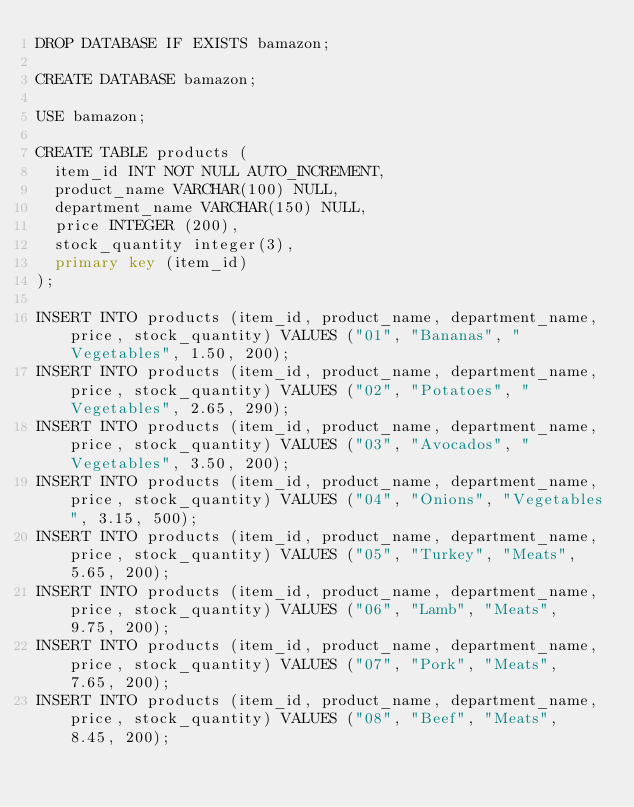Convert code to text. <code><loc_0><loc_0><loc_500><loc_500><_SQL_>DROP DATABASE IF EXISTS bamazon;

CREATE DATABASE bamazon;

USE bamazon;

CREATE TABLE products (
  item_id INT NOT NULL AUTO_INCREMENT,
  product_name VARCHAR(100) NULL,
  department_name VARCHAR(150) NULL,
  price INTEGER (200),
  stock_quantity integer(3),  
  primary key (item_id)
);

INSERT INTO products (item_id, product_name, department_name, price, stock_quantity) VALUES ("01", "Bananas", "Vegetables", 1.50, 200);
INSERT INTO products (item_id, product_name, department_name, price, stock_quantity) VALUES ("02", "Potatoes", "Vegetables", 2.65, 290);
INSERT INTO products (item_id, product_name, department_name, price, stock_quantity) VALUES ("03", "Avocados", "Vegetables", 3.50, 200);
INSERT INTO products (item_id, product_name, department_name, price, stock_quantity) VALUES ("04", "Onions", "Vegetables", 3.15, 500);
INSERT INTO products (item_id, product_name, department_name, price, stock_quantity) VALUES ("05", "Turkey", "Meats", 5.65, 200);
INSERT INTO products (item_id, product_name, department_name, price, stock_quantity) VALUES ("06", "Lamb", "Meats", 9.75, 200);
INSERT INTO products (item_id, product_name, department_name, price, stock_quantity) VALUES ("07", "Pork", "Meats", 7.65, 200);
INSERT INTO products (item_id, product_name, department_name, price, stock_quantity) VALUES ("08", "Beef", "Meats", 8.45, 200);</code> 